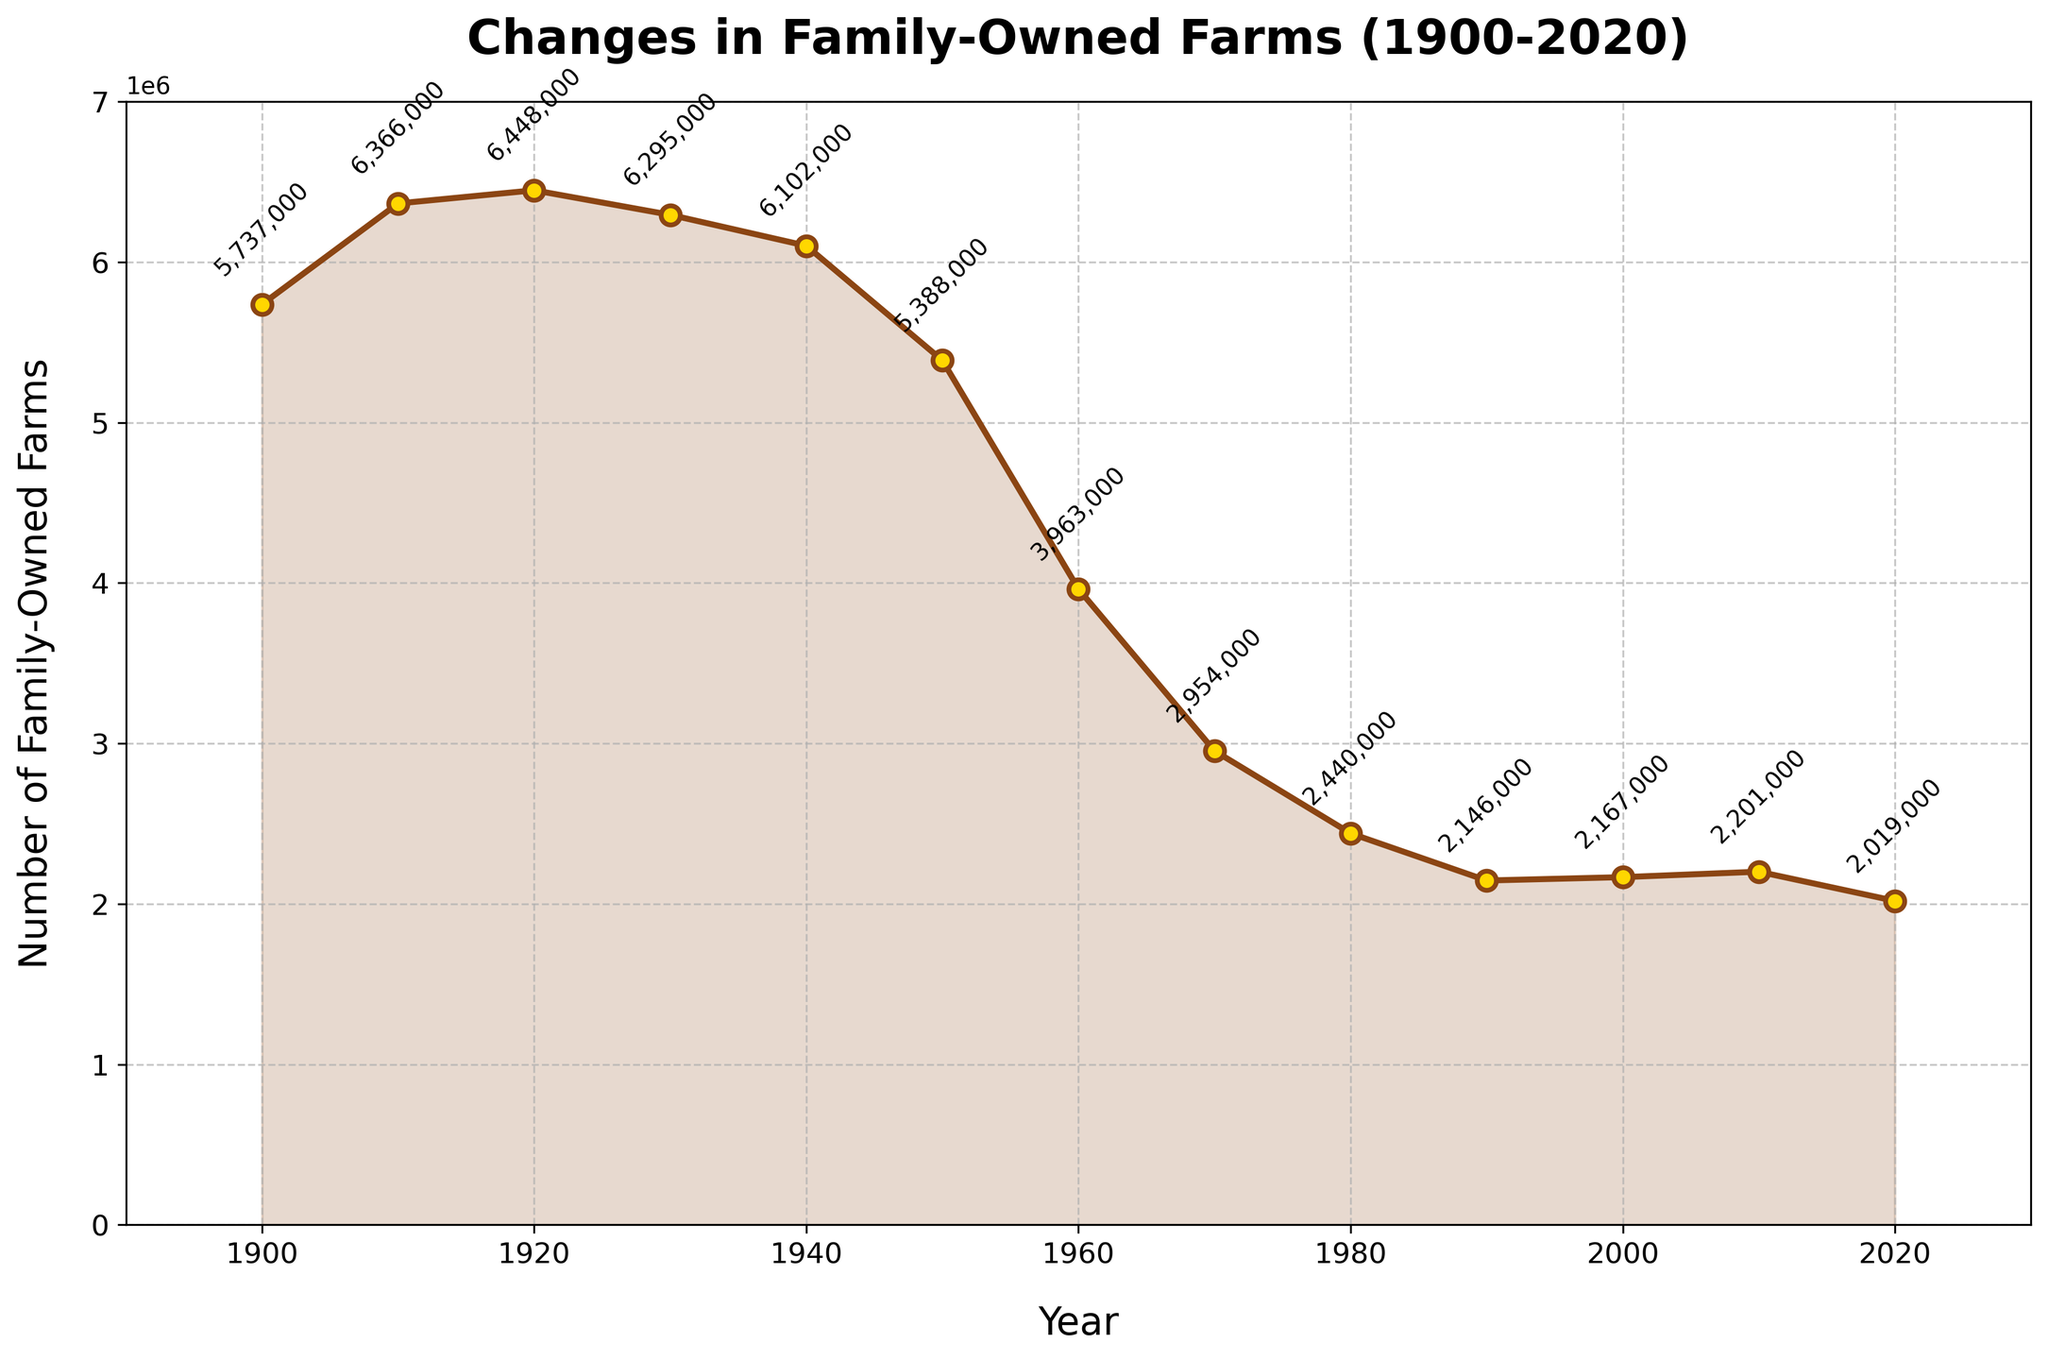what is the earliest year on the line chart? Look at the horizontal axis (X-axis) which shows the years, the earliest year on the leftmost side is 1900.
Answer: 1900 In which decade did the number of family-owned farms first start to decline? Look at the line from left to right, the first decline is between 1920 and 1930. Therefore, the decline started in the 1920s.
Answer: 1920s How much did the number of family-owned farms decrease from 1920 to 1930? Subtract the number of farms in 1930 from the number of farms in 1920 (6448000 - 6295000).
Answer: 153000 In which decade did the number of family-owned farms decrease the most? Compare the declines between each decade by visually observing the steepness of the line. The steepest decline is between 1950 and 1960.
Answer: 1950s What is the difference in the number of family-owned farms between 1900 and 2020? Subtract the number of farms in 2020 from the number of farms in 1900 (5737000 - 2019000).
Answer: 3718000 During which decade did the number of family-owned farms approximately stabilize, showing the least change? Look for a period where the line is relatively flat. Between 1990 and 2010, the line shows the least change.
Answer: 1990s-2010s What is the highest number of family-owned farms shown on the chart? Look for the peak of the line, which occurs around 1920 with 6448000 farms.
Answer: 6448000 Which year had the smallest number of family-owned farms? Find the lowest point on the line. In 2020, the lowest point is 2019000 farms.
Answer: 2020 In which decade did the number of family-owned farms increase? Examine the line trends for any upward movement. Between 2000 and 2010, there is a slight increase in the number of farms.
Answer: 2000s 